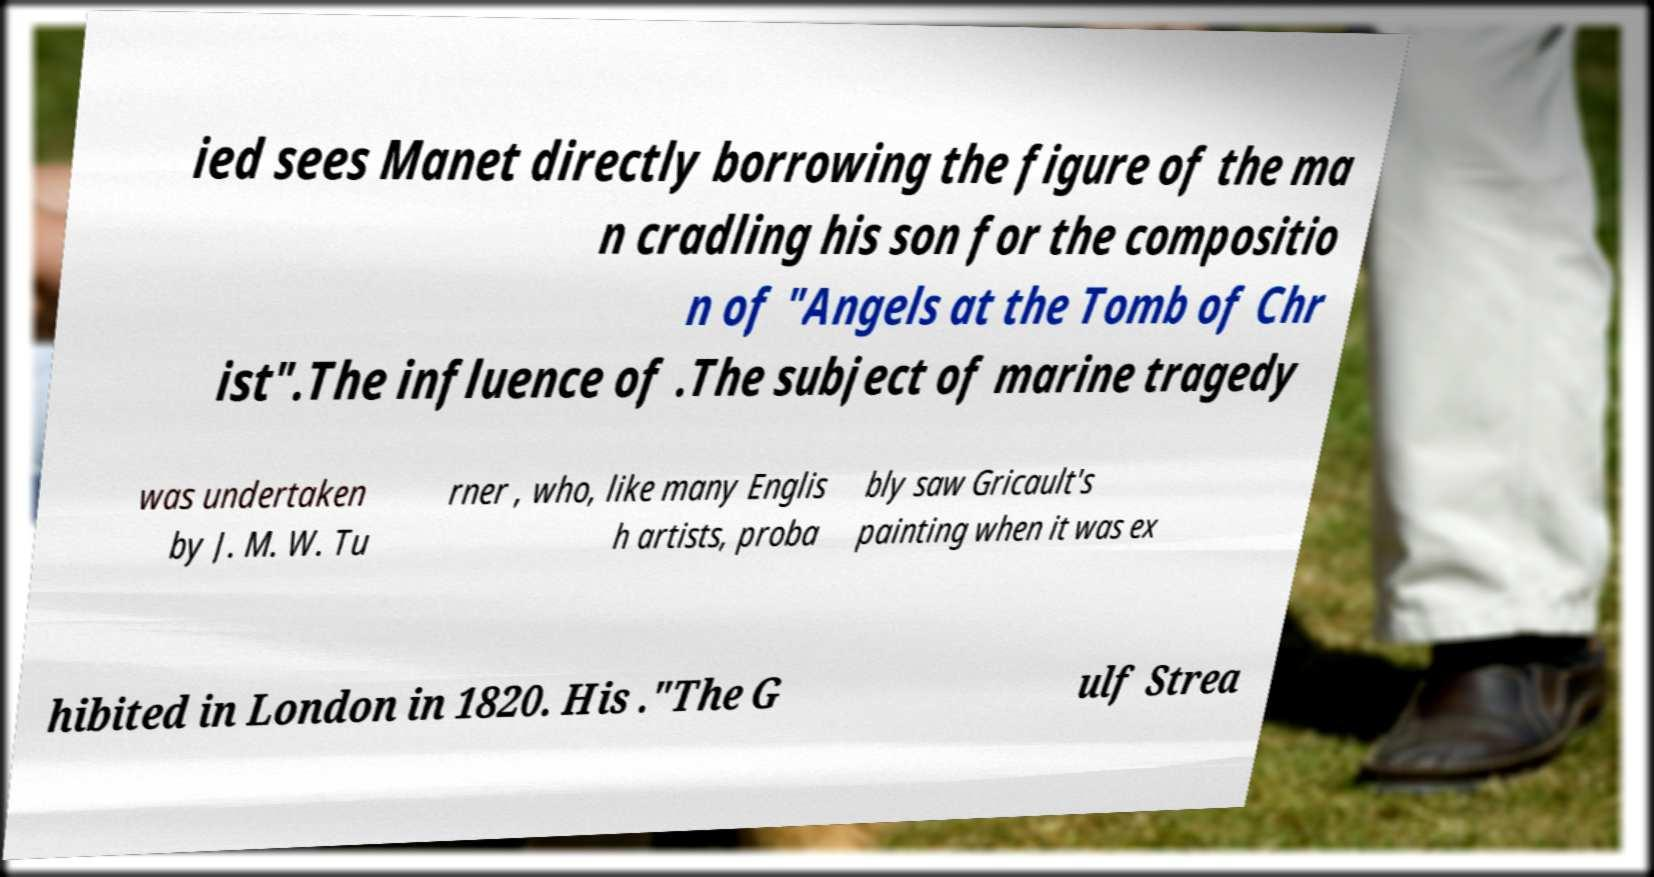I need the written content from this picture converted into text. Can you do that? ied sees Manet directly borrowing the figure of the ma n cradling his son for the compositio n of "Angels at the Tomb of Chr ist".The influence of .The subject of marine tragedy was undertaken by J. M. W. Tu rner , who, like many Englis h artists, proba bly saw Gricault's painting when it was ex hibited in London in 1820. His ."The G ulf Strea 